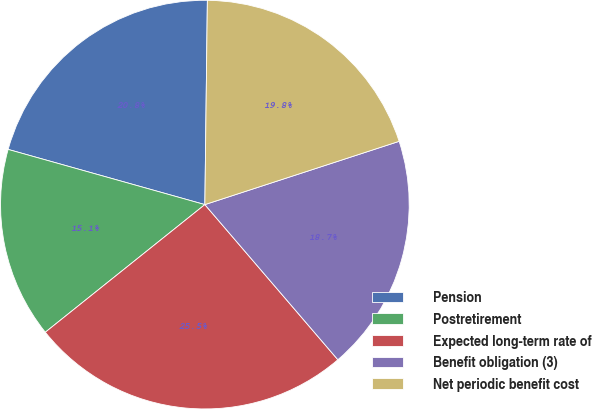<chart> <loc_0><loc_0><loc_500><loc_500><pie_chart><fcel>Pension<fcel>Postretirement<fcel>Expected long-term rate of<fcel>Benefit obligation (3)<fcel>Net periodic benefit cost<nl><fcel>20.84%<fcel>15.09%<fcel>25.54%<fcel>18.73%<fcel>19.79%<nl></chart> 